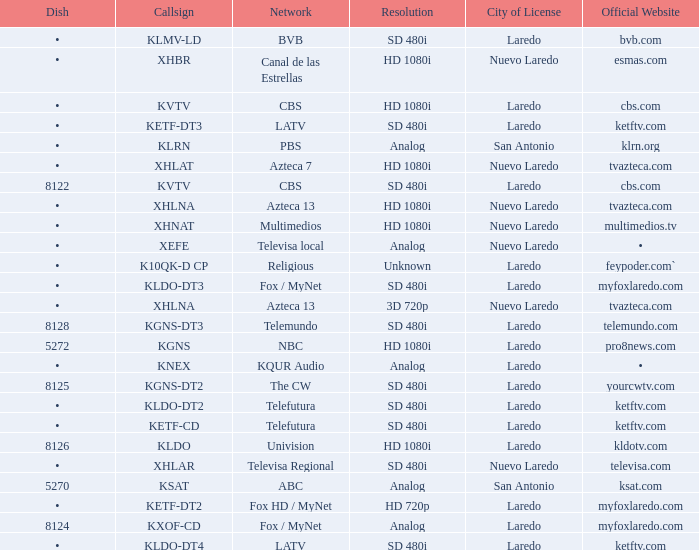Parse the table in full. {'header': ['Dish', 'Callsign', 'Network', 'Resolution', 'City of License', 'Official Website'], 'rows': [['•', 'KLMV-LD', 'BVB', 'SD 480i', 'Laredo', 'bvb.com'], ['•', 'XHBR', 'Canal de las Estrellas', 'HD 1080i', 'Nuevo Laredo', 'esmas.com'], ['•', 'KVTV', 'CBS', 'HD 1080i', 'Laredo', 'cbs.com'], ['•', 'KETF-DT3', 'LATV', 'SD 480i', 'Laredo', 'ketftv.com'], ['•', 'KLRN', 'PBS', 'Analog', 'San Antonio', 'klrn.org'], ['•', 'XHLAT', 'Azteca 7', 'HD 1080i', 'Nuevo Laredo', 'tvazteca.com'], ['8122', 'KVTV', 'CBS', 'SD 480i', 'Laredo', 'cbs.com'], ['•', 'XHLNA', 'Azteca 13', 'HD 1080i', 'Nuevo Laredo', 'tvazteca.com'], ['•', 'XHNAT', 'Multimedios', 'HD 1080i', 'Nuevo Laredo', 'multimedios.tv'], ['•', 'XEFE', 'Televisa local', 'Analog', 'Nuevo Laredo', '•'], ['•', 'K10QK-D CP', 'Religious', 'Unknown', 'Laredo', 'feypoder.com`'], ['•', 'KLDO-DT3', 'Fox / MyNet', 'SD 480i', 'Laredo', 'myfoxlaredo.com'], ['•', 'XHLNA', 'Azteca 13', '3D 720p', 'Nuevo Laredo', 'tvazteca.com'], ['8128', 'KGNS-DT3', 'Telemundo', 'SD 480i', 'Laredo', 'telemundo.com'], ['5272', 'KGNS', 'NBC', 'HD 1080i', 'Laredo', 'pro8news.com'], ['•', 'KNEX', 'KQUR Audio', 'Analog', 'Laredo', '•'], ['8125', 'KGNS-DT2', 'The CW', 'SD 480i', 'Laredo', 'yourcwtv.com'], ['•', 'KLDO-DT2', 'Telefutura', 'SD 480i', 'Laredo', 'ketftv.com'], ['•', 'KETF-CD', 'Telefutura', 'SD 480i', 'Laredo', 'ketftv.com'], ['8126', 'KLDO', 'Univision', 'HD 1080i', 'Laredo', 'kldotv.com'], ['•', 'XHLAR', 'Televisa Regional', 'SD 480i', 'Nuevo Laredo', 'televisa.com'], ['5270', 'KSAT', 'ABC', 'Analog', 'San Antonio', 'ksat.com'], ['•', 'KETF-DT2', 'Fox HD / MyNet', 'HD 720p', 'Laredo', 'myfoxlaredo.com'], ['8124', 'KXOF-CD', 'Fox / MyNet', 'Analog', 'Laredo', 'myfoxlaredo.com'], ['•', 'KLDO-DT4', 'LATV', 'SD 480i', 'Laredo', 'ketftv.com']]} Name the official website which has dish of • and callsign of kvtv Cbs.com. 